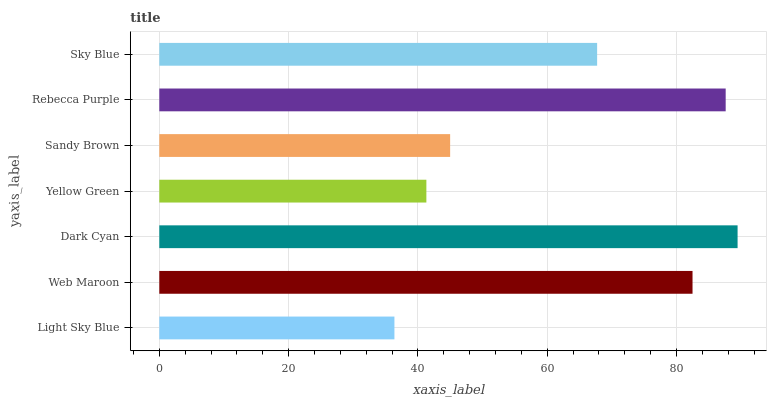Is Light Sky Blue the minimum?
Answer yes or no. Yes. Is Dark Cyan the maximum?
Answer yes or no. Yes. Is Web Maroon the minimum?
Answer yes or no. No. Is Web Maroon the maximum?
Answer yes or no. No. Is Web Maroon greater than Light Sky Blue?
Answer yes or no. Yes. Is Light Sky Blue less than Web Maroon?
Answer yes or no. Yes. Is Light Sky Blue greater than Web Maroon?
Answer yes or no. No. Is Web Maroon less than Light Sky Blue?
Answer yes or no. No. Is Sky Blue the high median?
Answer yes or no. Yes. Is Sky Blue the low median?
Answer yes or no. Yes. Is Dark Cyan the high median?
Answer yes or no. No. Is Web Maroon the low median?
Answer yes or no. No. 